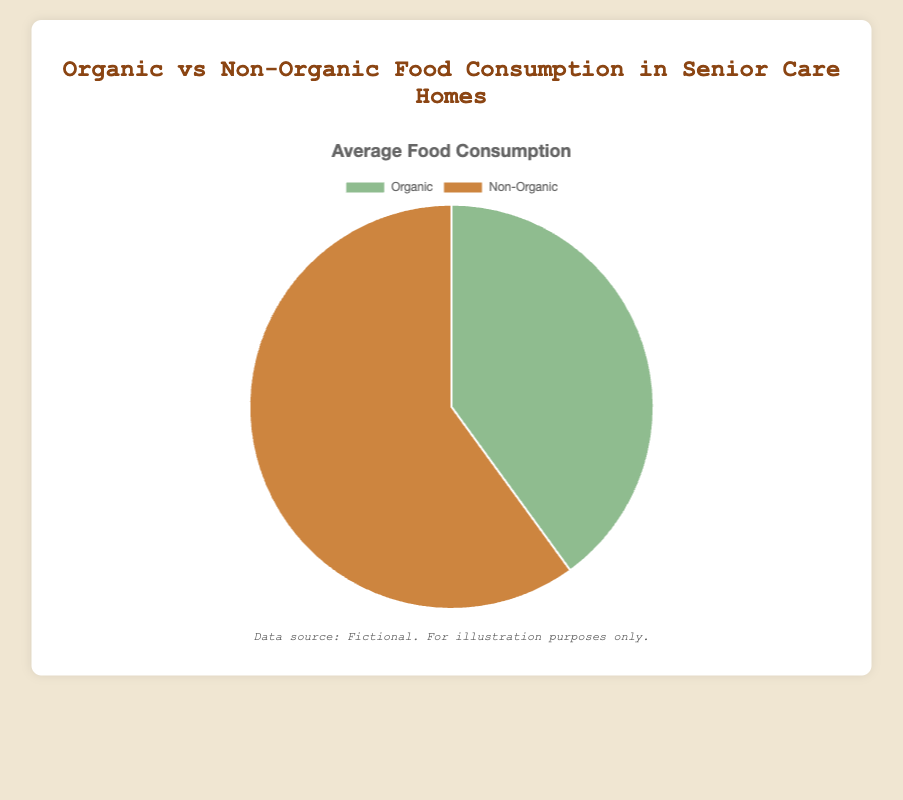What is the percentage of non-organic food consumption at Brookdale Senior Living? The figure shows the average food consumption percentages where non-organic food is represented by one of the sections of the pie chart. For Brookdale Senior Living, the non-organic food consumption percentage is listed as 60%.
Answer: 60% Which senior care home has the highest percentage of organic food consumption? To determine which senior care home has the highest percentage of organic food consumption, refer to the dataset for the percentage values of each care home. Five Star Senior Living has the highest percentage at 50%.
Answer: Five Star Senior Living Compare the organic food consumption percentage between Sunrise Senior Living and Holiday Retirement. Which one is higher and by how much? Sunrise Senior Living has an organic food consumption of 35%, while Holiday Retirement has 30%. To find out which is higher and by how much, subtract Holiday Retirement's percentage from Sunrise Senior Living's. 35% - 30% = 5%.
Answer: Sunrise Senior Living by 5% Calculate the average percentage of non-organic food consumption across all senior care homes. Sum the non-organic food consumption percentages for all homes: 65 + 60 + 55 + 70 + 50 = 300. Divide by the number of homes: 300 / 5 = 60%.
Answer: 60% If the total food consumption is 100%, what is the ratio of organic to non-organic food consumption at Atria Senior Living? For Atria Senior Living, the organic food consumption is 45% and non-organic consumption is 55%. The ratio is 45:55. Simplify the ratio by dividing both numbers by 5, resulting in 9:11.
Answer: 9:11 Which visual element differentiates between organic and non-organic food in the pie chart? The two segments of the pie chart are differentiated by their colors. Organic food is shown in a green tint, while non-organic food is shown in a brownish tint, based on the chart's color scheme.
Answer: Color What is the combined percentage of organic food consumption for Brookdale Senior Living and Atria Senior Living? Sum the organic food consumption percentages for both Brookdale Senior Living (40%) and Atria Senior Living (45%) to find the combined total. 40% + 45% = 85%.
Answer: 85% Which senior care home has an equal percentage of organic and non-organic food consumption? From the dataset, Five Star Senior Living is listed as having 50% organic and 50% non-organic food consumption, making it equal.
Answer: Five Star Senior Living Is the average percentage of organic food consumption higher or lower than 40% across the senior care homes? To find the average organic food consumption, sum the percentages for all homes: 35 + 40 + 45 + 30 + 50 = 200. Divide by the number of homes: 200 / 5 = 40%. The average percentage of organic food consumption is 40%, so it is equal to 40%.
Answer: Equal What care home has the largest discrepancy between organic and non-organic food consumption percentages? The care home with the largest discrepancy can be identified by calculating the difference between the percentages of organic and non-organic consumption for each home. Holiday Retirement has a 40% difference (70% non-organic - 30% organic), which is the highest discrepancy.
Answer: Holiday Retirement 